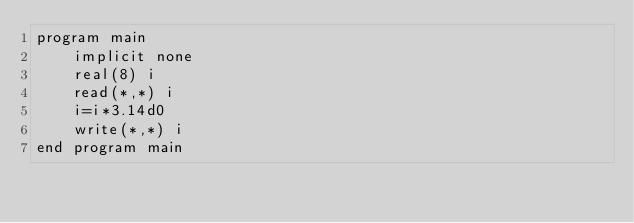<code> <loc_0><loc_0><loc_500><loc_500><_FORTRAN_>program main
    implicit none
    real(8) i
    read(*,*) i
    i=i*3.14d0
    write(*,*) i
end program main</code> 